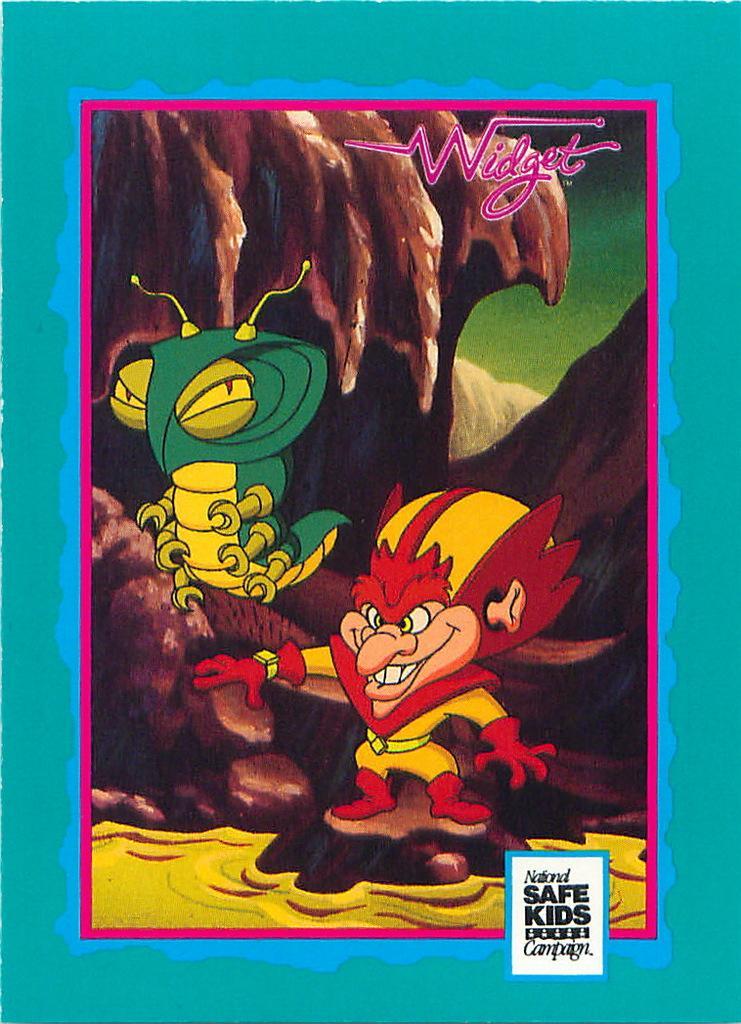Please provide a concise description of this image. In the center of this picture we can see a cartoon of a person and a cartoon of an animal. In the background we can see the rocks and we can see the borders and the text on the image. 